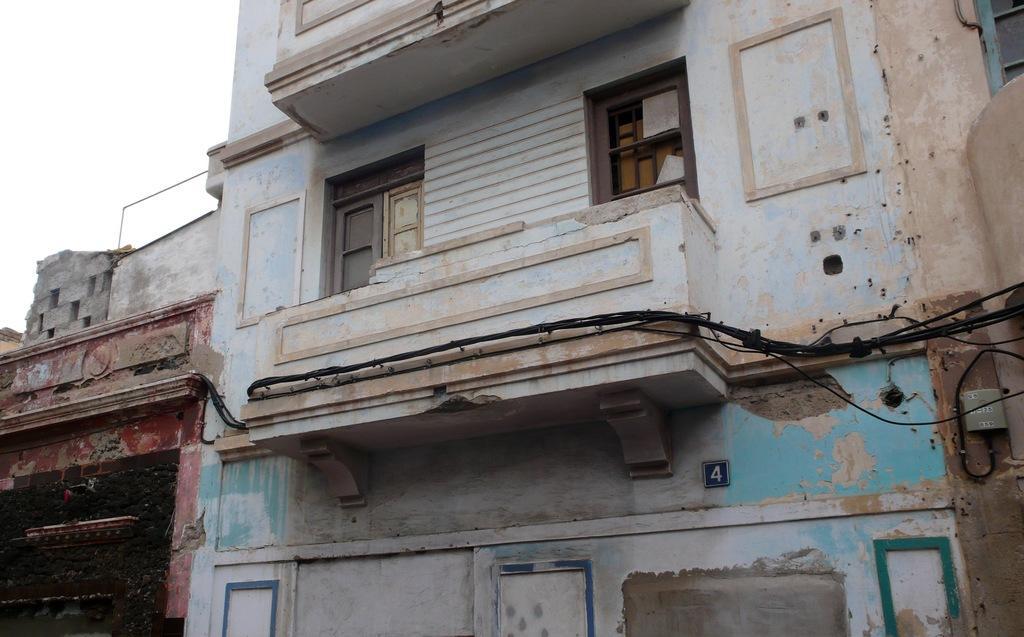Please provide a concise description of this image. In this image, we can see few hoses, wall, wires, window. Here we can see a number plate. Left side top of the image, we can see the sky. 